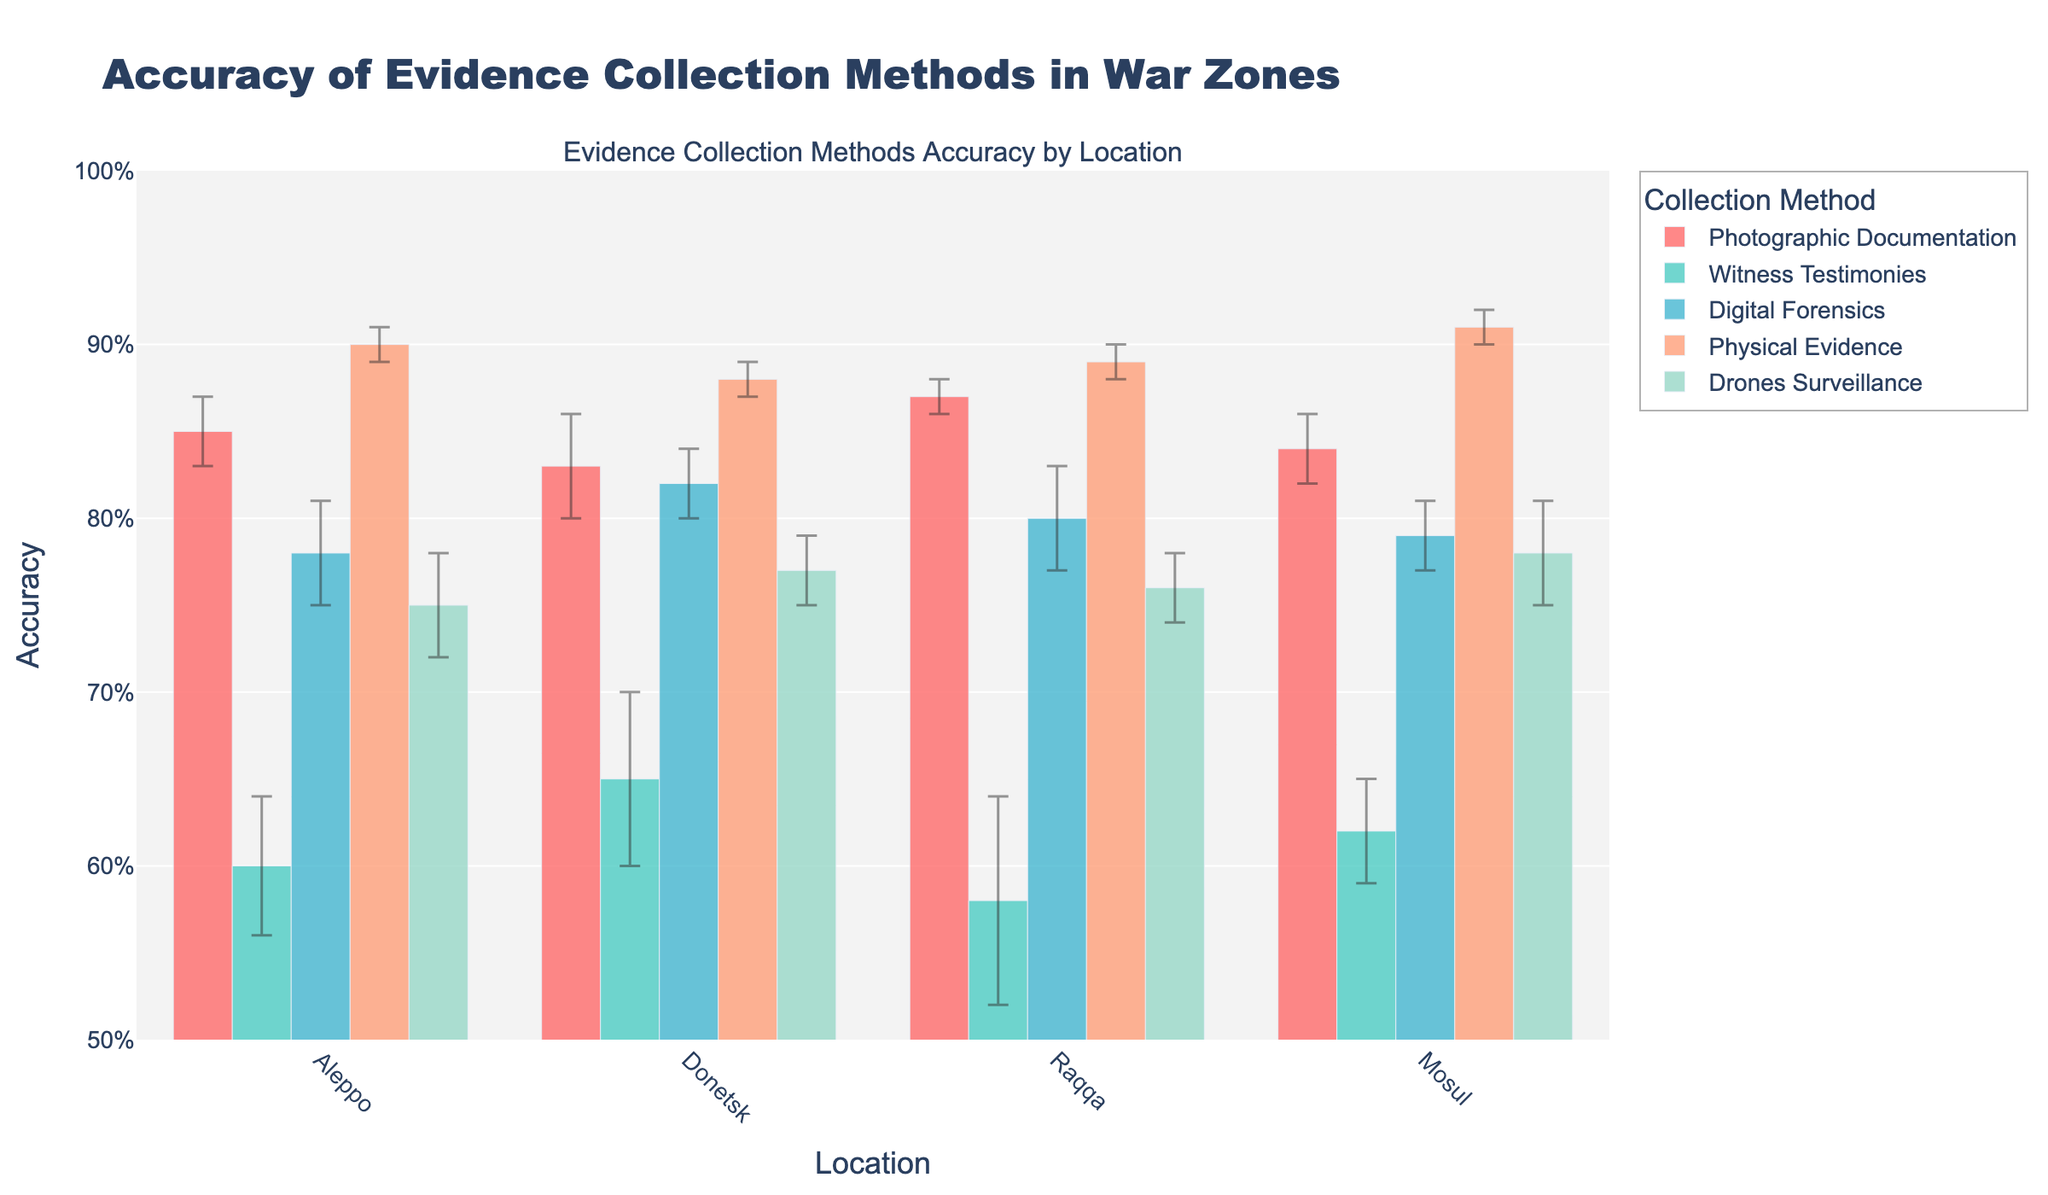What is the title of the plot? The title is usually displayed at the top of the figure. In this case, it reads 'Accuracy of Evidence Collection Methods in War Zones'.
Answer: Accuracy of Evidence Collection Methods in War Zones Which collection method shows the highest accuracy in Aleppo? Refer to the bars representing accuracy for each method in Aleppo. The bar for 'Physical Evidence' reaches 0.90, which is the highest.
Answer: Physical Evidence How does the accuracy of Witness Testimonies compare between Aleppo and Donetsk? Look at the bars for Witness Testimonies in both Aleppo and Donetsk. Aleppo has an accuracy of 0.60, while Donetsk has 0.65. Donetsk is higher.
Answer: Donetsk is higher What is the range of error margins for Drones Surveillance across all locations? Error margins for Drones Surveillance in Aleppo, Donetsk, Raqqa, and Mosul are 0.03, 0.02, 0.02, and 0.03, respectively. The range is from 0.02 to 0.03.
Answer: 0.02 to 0.03 Which location has the highest overall accuracy for Physical Evidence? Check the bars for Physical Evidence across all locations. Mosul has the highest accuracy with 0.91.
Answer: Mosul What is the average accuracy of Digital Forensics across all locations? Sum all the accuracies for Digital Forensics across Aleppo (0.78), Donetsk (0.82), Raqqa (0.80), and Mosul (0.79), then divide by 4. The average is (0.78 + 0.82 + 0.80 + 0.79) / 4 = 0.7975.
Answer: 0.7975 How do the error margins for Witness Testimonies in Raqqa compare to Mosul? Check the error margins for Witness Testimonies in Raqqa (0.06) and Mosul (0.03). Raqqa has a higher error margin.
Answer: Raqqa is higher Is the accuracy of Photographic Documentation in Raqqa higher than in Mosul? Compare the bars for Photographic Documentation in Raqqa and Mosul. Raqqa shows 0.87, and Mosul shows 0.84. Yes, it's higher in Raqqa.
Answer: Yes What is the difference in accuracy between Digital Forensics and Drones Surveillance in Donetsk? Accuracy for Digital Forensics in Donetsk is 0.82, and for Drones Surveillance, it is 0.77. The difference (0.82 - 0.77) is 0.05.
Answer: 0.05 In which location is the variance in accuracy the highest among all evidence collection methods? Consider error margins as a reflection of variance. The largest error margin appears for Witness Testimonies in Raqqa with 0.06. So, Raqqa has the highest variance.
Answer: Raqqa 